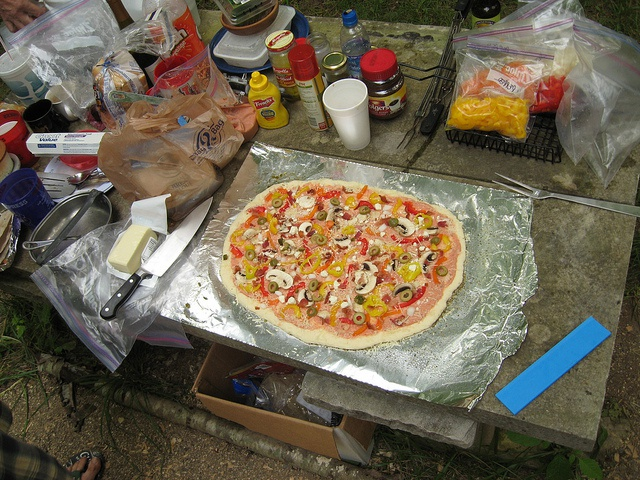Describe the objects in this image and their specific colors. I can see dining table in maroon, gray, darkgreen, darkgray, and black tones, pizza in maroon, tan, and brown tones, cup in maroon, lightgray, darkgray, and gray tones, bottle in maroon, black, brown, and olive tones, and knife in maroon, white, gray, darkgray, and black tones in this image. 